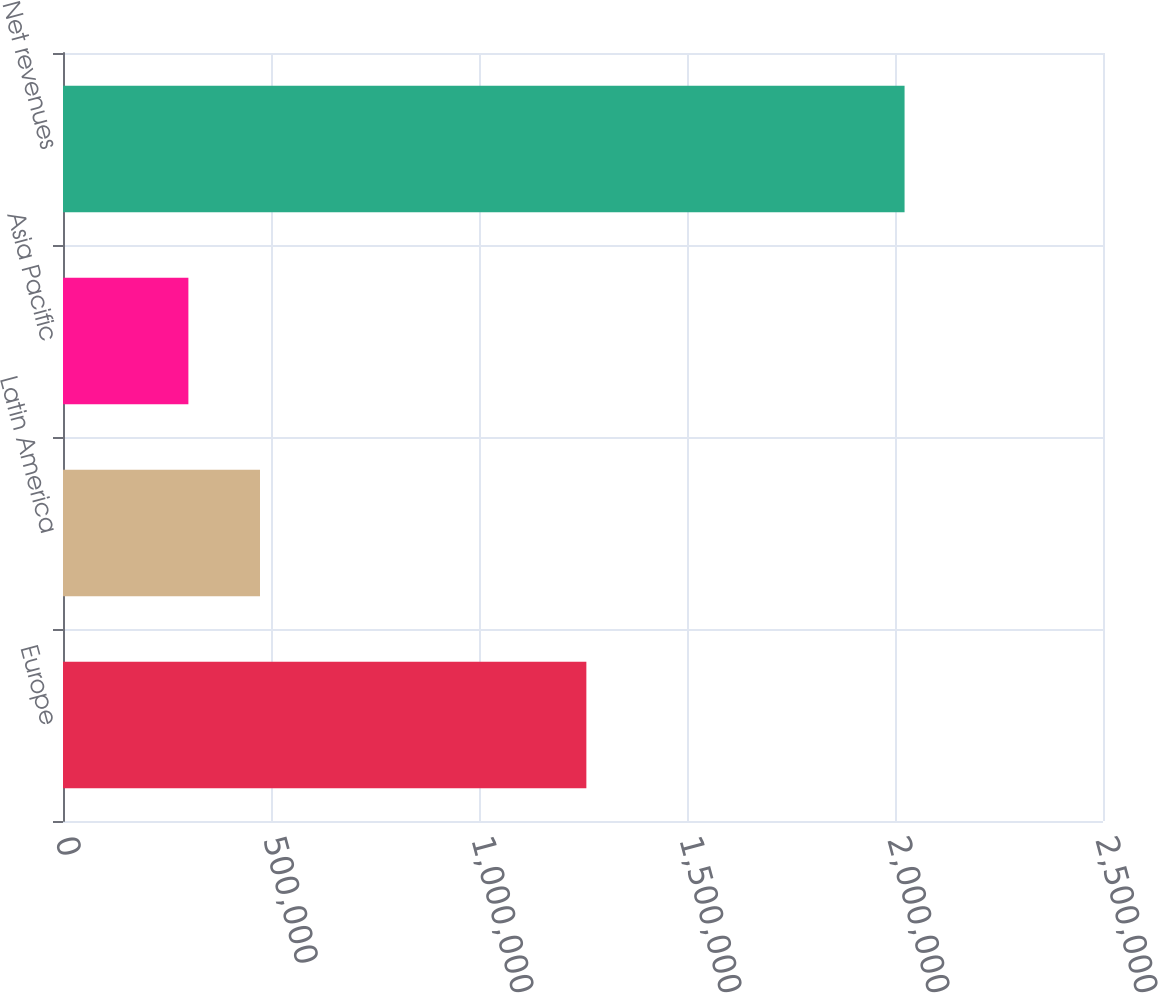Convert chart. <chart><loc_0><loc_0><loc_500><loc_500><bar_chart><fcel>Europe<fcel>Latin America<fcel>Asia Pacific<fcel>Net revenues<nl><fcel>1.25808e+06<fcel>473566<fcel>301407<fcel>2.023e+06<nl></chart> 